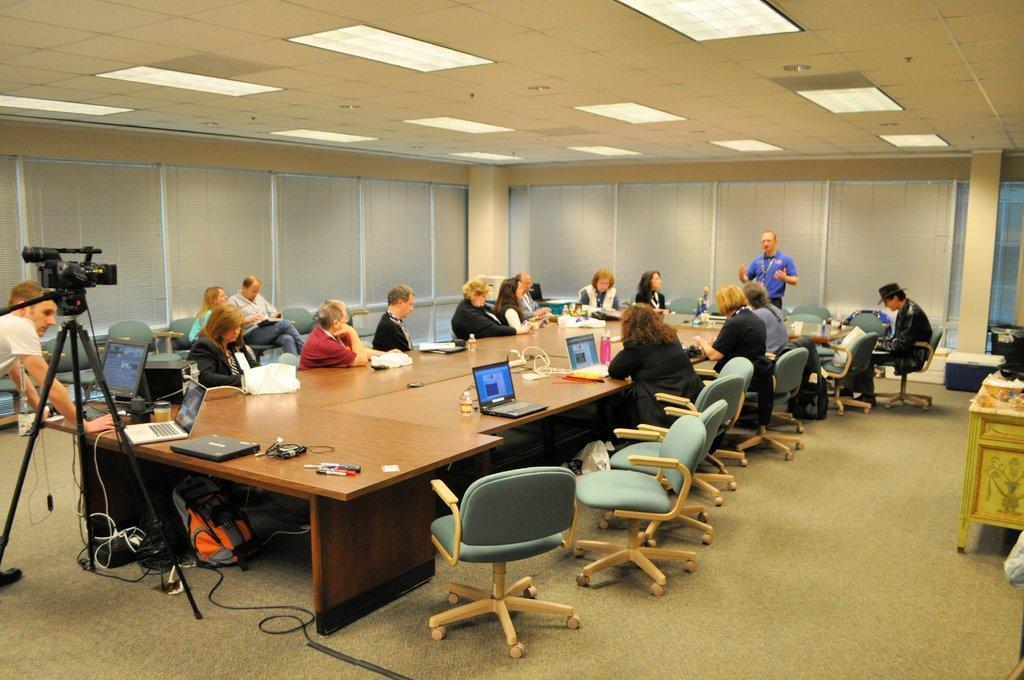How many people are in the image? There is a group of people in the image. What are the people doing in the image? The people are sitting around chairs. Is there anyone standing in the image? Yes, there is a man standing in the image. What is the man doing in the image? The man is talking. What is the angle of the slope in the image? There is no slope present in the image. Can you describe the veins in the man's arm in the image? There is no visible arm or veins in the image; the man is standing and talking. 